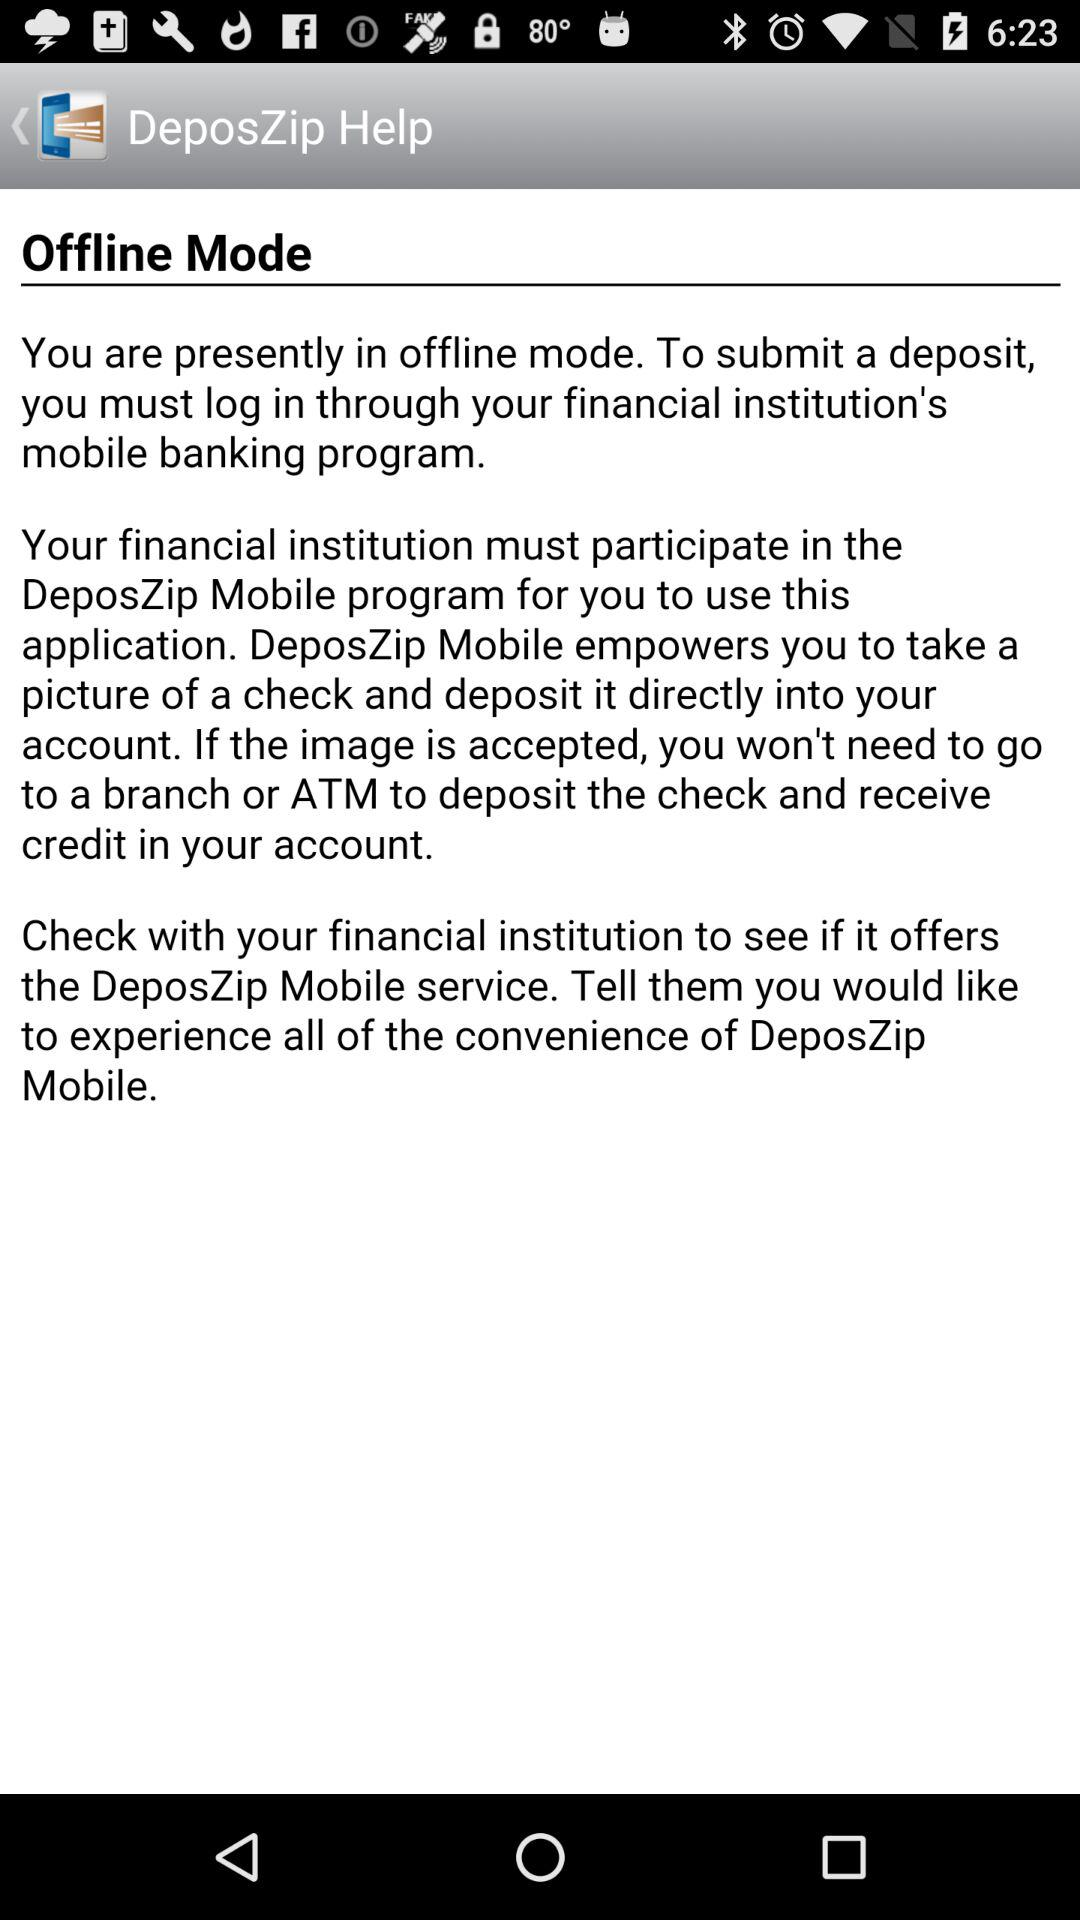The application is in what mode? The application is in offline mode. 